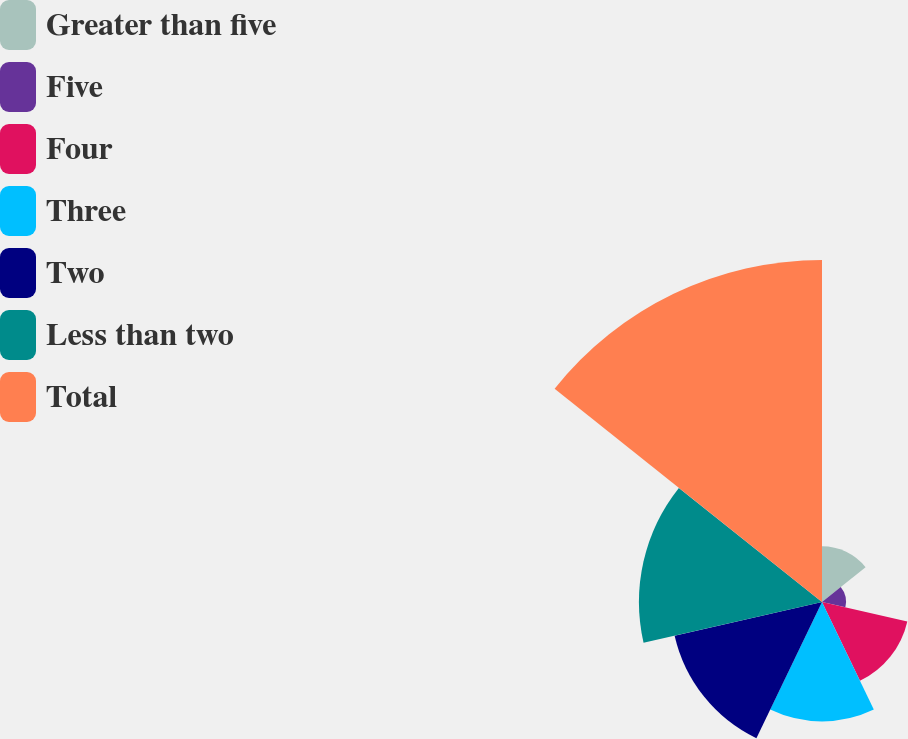<chart> <loc_0><loc_0><loc_500><loc_500><pie_chart><fcel>Greater than five<fcel>Five<fcel>Four<fcel>Three<fcel>Two<fcel>Less than two<fcel>Total<nl><fcel>5.79%<fcel>2.49%<fcel>9.09%<fcel>12.4%<fcel>15.7%<fcel>19.01%<fcel>35.52%<nl></chart> 